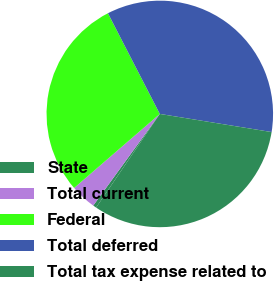Convert chart to OTSL. <chart><loc_0><loc_0><loc_500><loc_500><pie_chart><fcel>State<fcel>Total current<fcel>Federal<fcel>Total deferred<fcel>Total tax expense related to<nl><fcel>0.49%<fcel>3.66%<fcel>28.77%<fcel>35.13%<fcel>31.95%<nl></chart> 